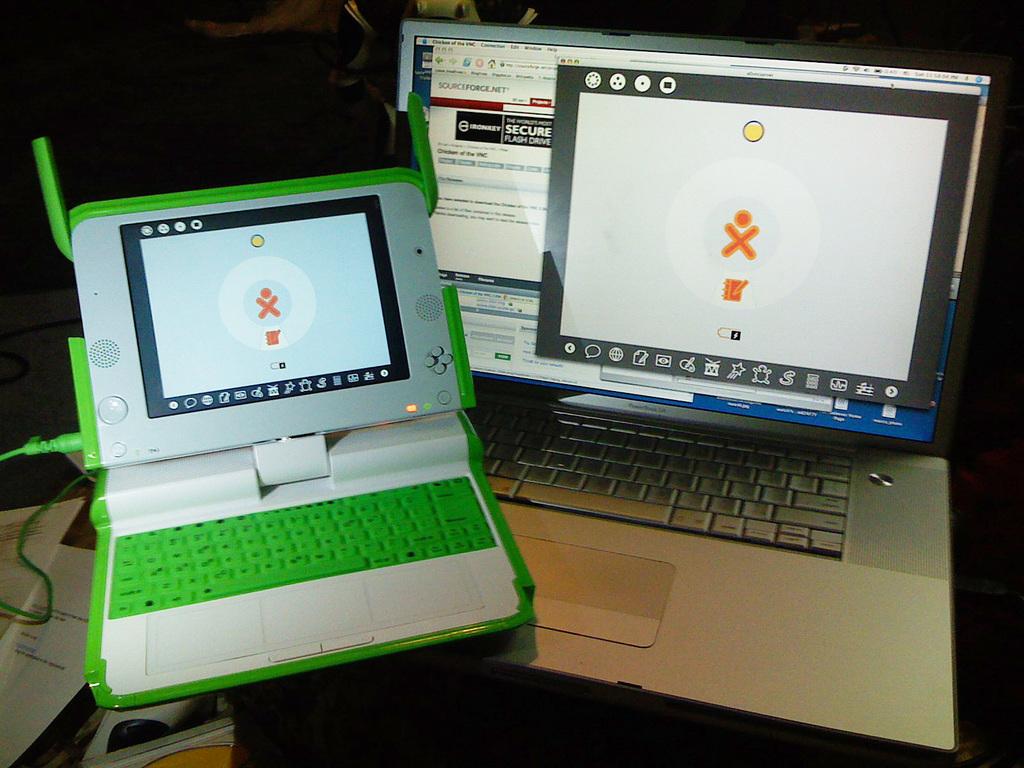Is that a qwerty keyboard?
Ensure brevity in your answer.  Yes. 